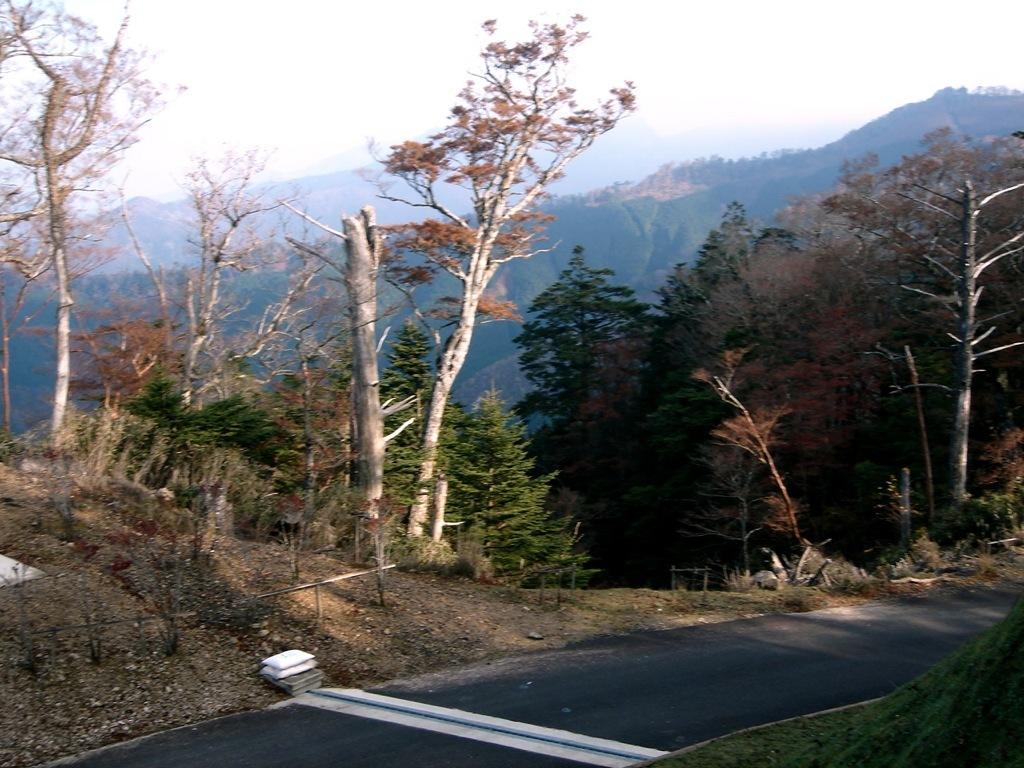Please provide a concise description of this image. In the picture I can see the road at the bottom of the picture. There are trees on the side of the road. In the background, I can see the hills. 